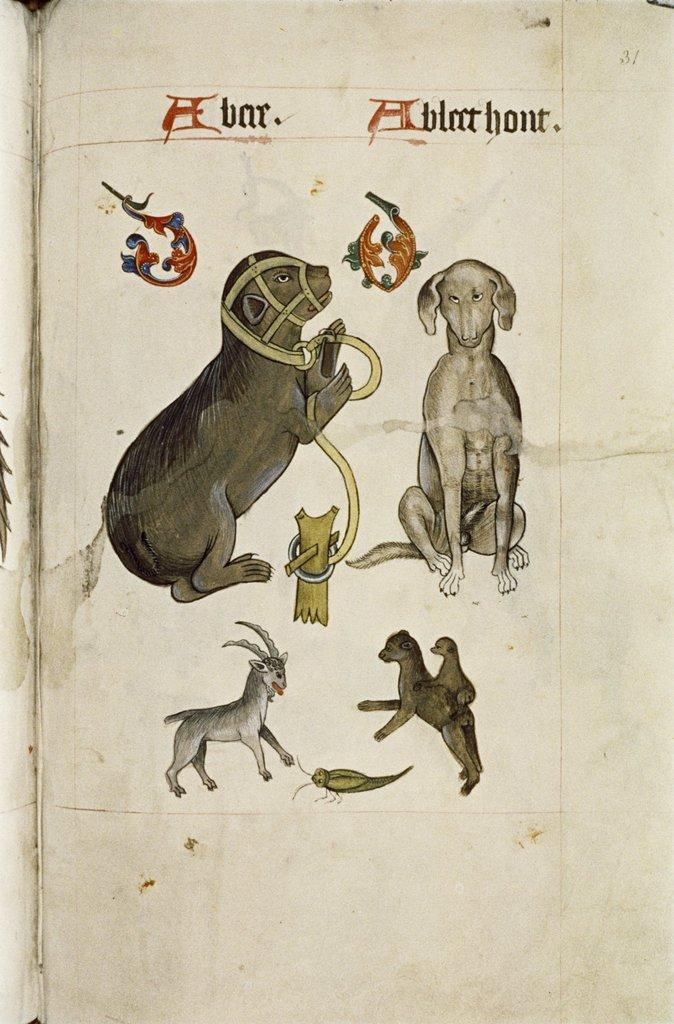What type of content is shown in the image? The image is a page from a book. What animals can be seen in the image? There is a dog and a goat in the image, as well as other animals. What type of lettuce is being used as a pillow for the alarm in the image? There is no lettuce or alarm present in the image; it features a page from a book with various animals. 